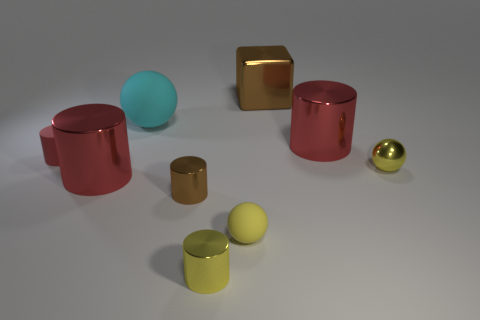There is a yellow thing to the right of the large red metallic thing behind the yellow object right of the large brown thing; what size is it?
Your answer should be very brief. Small. There is a small object that is the same color as the block; what is it made of?
Provide a short and direct response. Metal. Is there any other thing that has the same shape as the big brown object?
Ensure brevity in your answer.  No. How big is the cylinder that is in front of the tiny rubber thing that is in front of the metal ball?
Keep it short and to the point. Small. How many tiny things are either cylinders or yellow rubber objects?
Make the answer very short. 4. Is the number of tiny gray things less than the number of things?
Your response must be concise. Yes. Is the color of the big rubber sphere the same as the tiny metallic ball?
Make the answer very short. No. Are there more green objects than small yellow metal spheres?
Offer a very short reply. No. What number of other things are the same color as the tiny metal ball?
Provide a succinct answer. 2. There is a rubber ball that is in front of the red rubber thing; what number of small yellow balls are right of it?
Make the answer very short. 1. 